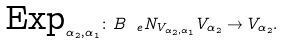<formula> <loc_0><loc_0><loc_500><loc_500>\text {Exp} _ { \alpha _ { 2 } , \alpha _ { 1 } } \colon B _ { \ e } N _ { V _ { \alpha _ { 2 } , \alpha _ { 1 } } } V _ { \alpha _ { 2 } } \to V _ { \alpha _ { 2 } } .</formula> 